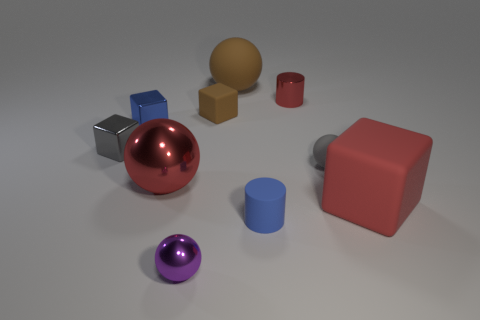Subtract all cylinders. How many objects are left? 8 Add 6 small metallic cylinders. How many small metallic cylinders exist? 7 Subtract 0 brown cylinders. How many objects are left? 10 Subtract all cyan cylinders. Subtract all large cubes. How many objects are left? 9 Add 1 big brown rubber things. How many big brown rubber things are left? 2 